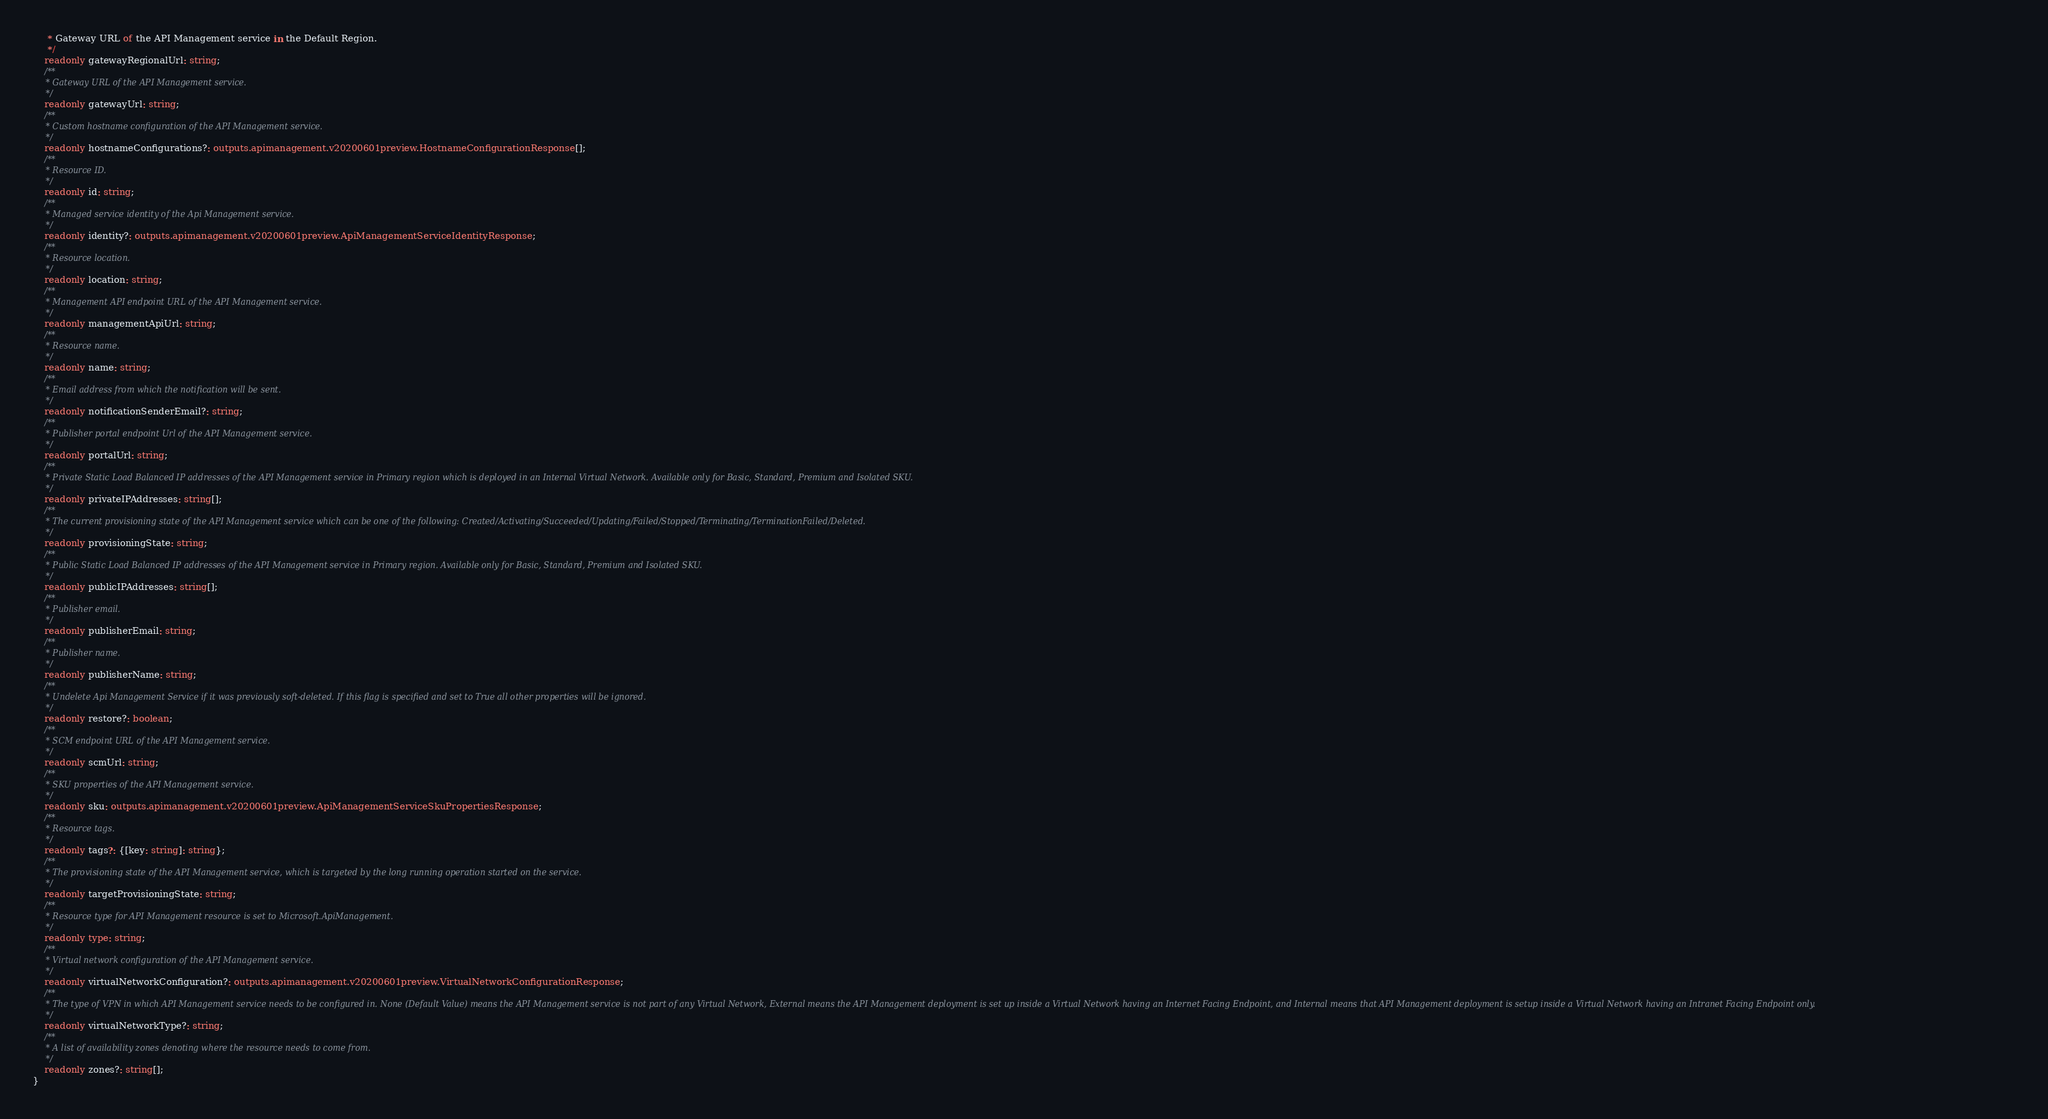Convert code to text. <code><loc_0><loc_0><loc_500><loc_500><_TypeScript_>     * Gateway URL of the API Management service in the Default Region.
     */
    readonly gatewayRegionalUrl: string;
    /**
     * Gateway URL of the API Management service.
     */
    readonly gatewayUrl: string;
    /**
     * Custom hostname configuration of the API Management service.
     */
    readonly hostnameConfigurations?: outputs.apimanagement.v20200601preview.HostnameConfigurationResponse[];
    /**
     * Resource ID.
     */
    readonly id: string;
    /**
     * Managed service identity of the Api Management service.
     */
    readonly identity?: outputs.apimanagement.v20200601preview.ApiManagementServiceIdentityResponse;
    /**
     * Resource location.
     */
    readonly location: string;
    /**
     * Management API endpoint URL of the API Management service.
     */
    readonly managementApiUrl: string;
    /**
     * Resource name.
     */
    readonly name: string;
    /**
     * Email address from which the notification will be sent.
     */
    readonly notificationSenderEmail?: string;
    /**
     * Publisher portal endpoint Url of the API Management service.
     */
    readonly portalUrl: string;
    /**
     * Private Static Load Balanced IP addresses of the API Management service in Primary region which is deployed in an Internal Virtual Network. Available only for Basic, Standard, Premium and Isolated SKU.
     */
    readonly privateIPAddresses: string[];
    /**
     * The current provisioning state of the API Management service which can be one of the following: Created/Activating/Succeeded/Updating/Failed/Stopped/Terminating/TerminationFailed/Deleted.
     */
    readonly provisioningState: string;
    /**
     * Public Static Load Balanced IP addresses of the API Management service in Primary region. Available only for Basic, Standard, Premium and Isolated SKU.
     */
    readonly publicIPAddresses: string[];
    /**
     * Publisher email.
     */
    readonly publisherEmail: string;
    /**
     * Publisher name.
     */
    readonly publisherName: string;
    /**
     * Undelete Api Management Service if it was previously soft-deleted. If this flag is specified and set to True all other properties will be ignored.
     */
    readonly restore?: boolean;
    /**
     * SCM endpoint URL of the API Management service.
     */
    readonly scmUrl: string;
    /**
     * SKU properties of the API Management service.
     */
    readonly sku: outputs.apimanagement.v20200601preview.ApiManagementServiceSkuPropertiesResponse;
    /**
     * Resource tags.
     */
    readonly tags?: {[key: string]: string};
    /**
     * The provisioning state of the API Management service, which is targeted by the long running operation started on the service.
     */
    readonly targetProvisioningState: string;
    /**
     * Resource type for API Management resource is set to Microsoft.ApiManagement.
     */
    readonly type: string;
    /**
     * Virtual network configuration of the API Management service.
     */
    readonly virtualNetworkConfiguration?: outputs.apimanagement.v20200601preview.VirtualNetworkConfigurationResponse;
    /**
     * The type of VPN in which API Management service needs to be configured in. None (Default Value) means the API Management service is not part of any Virtual Network, External means the API Management deployment is set up inside a Virtual Network having an Internet Facing Endpoint, and Internal means that API Management deployment is setup inside a Virtual Network having an Intranet Facing Endpoint only.
     */
    readonly virtualNetworkType?: string;
    /**
     * A list of availability zones denoting where the resource needs to come from.
     */
    readonly zones?: string[];
}
</code> 